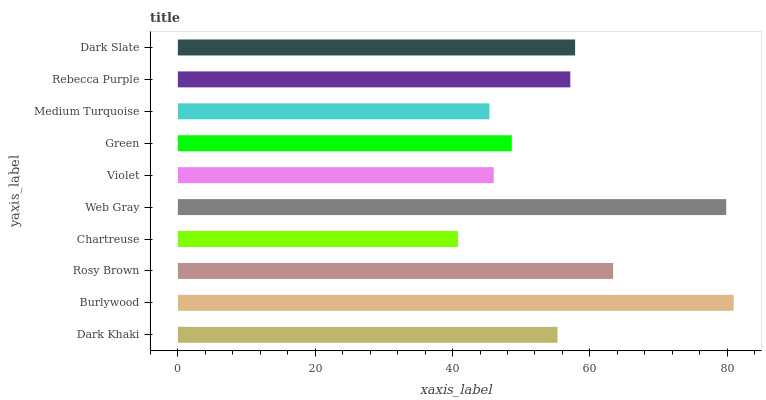Is Chartreuse the minimum?
Answer yes or no. Yes. Is Burlywood the maximum?
Answer yes or no. Yes. Is Rosy Brown the minimum?
Answer yes or no. No. Is Rosy Brown the maximum?
Answer yes or no. No. Is Burlywood greater than Rosy Brown?
Answer yes or no. Yes. Is Rosy Brown less than Burlywood?
Answer yes or no. Yes. Is Rosy Brown greater than Burlywood?
Answer yes or no. No. Is Burlywood less than Rosy Brown?
Answer yes or no. No. Is Rebecca Purple the high median?
Answer yes or no. Yes. Is Dark Khaki the low median?
Answer yes or no. Yes. Is Web Gray the high median?
Answer yes or no. No. Is Rebecca Purple the low median?
Answer yes or no. No. 